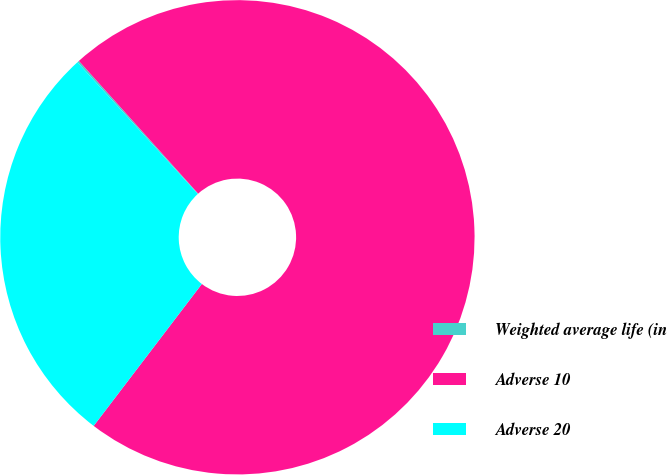Convert chart. <chart><loc_0><loc_0><loc_500><loc_500><pie_chart><fcel>Weighted average life (in<fcel>Adverse 10<fcel>Adverse 20<nl><fcel>0.13%<fcel>72.02%<fcel>27.85%<nl></chart> 